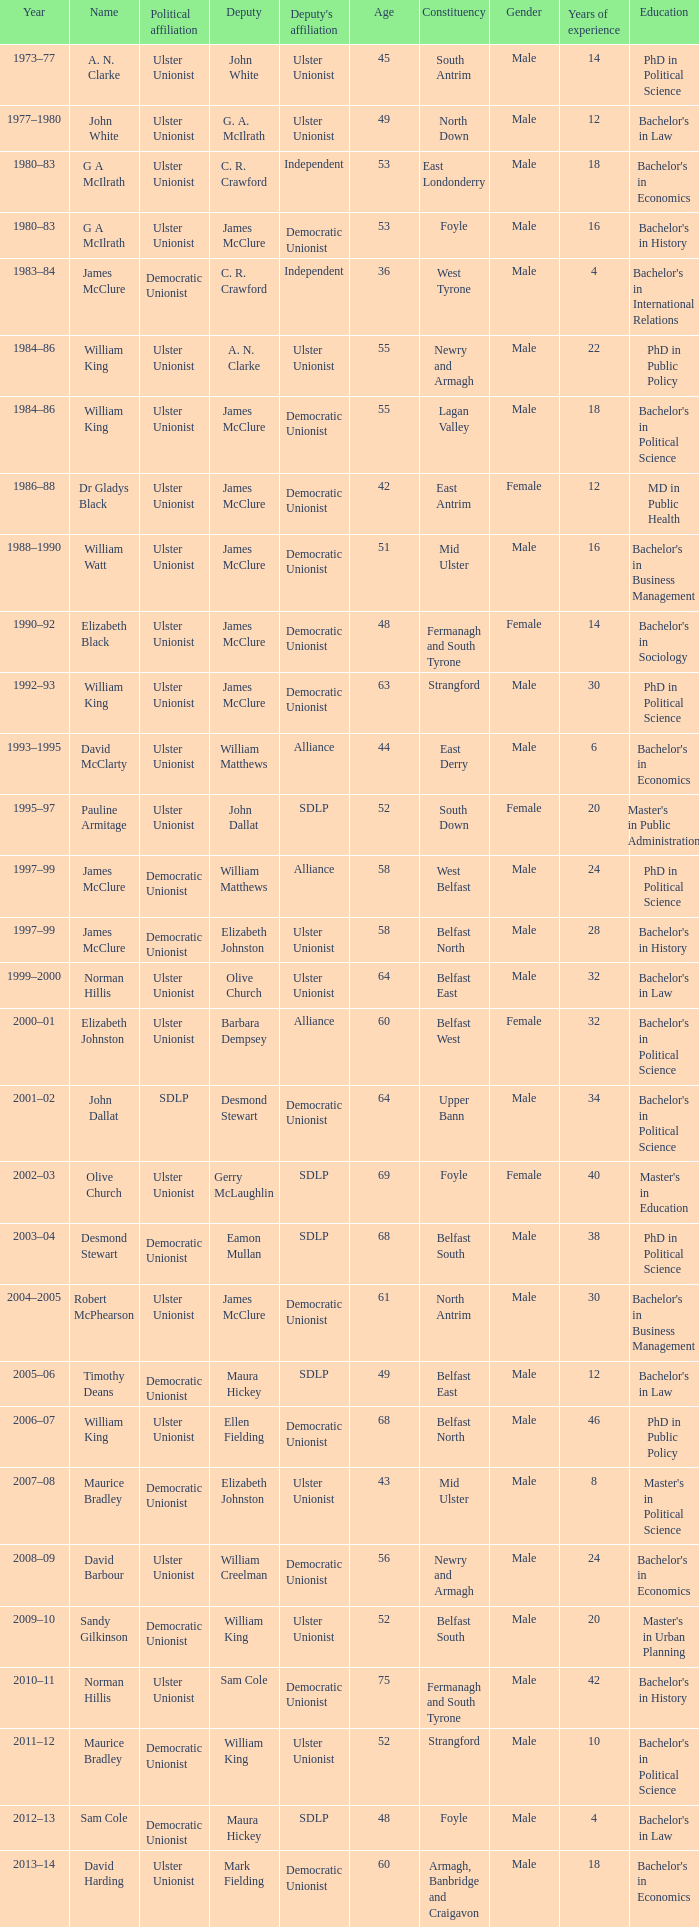What is the name of the Deputy when the Name was elizabeth black? James McClure. 